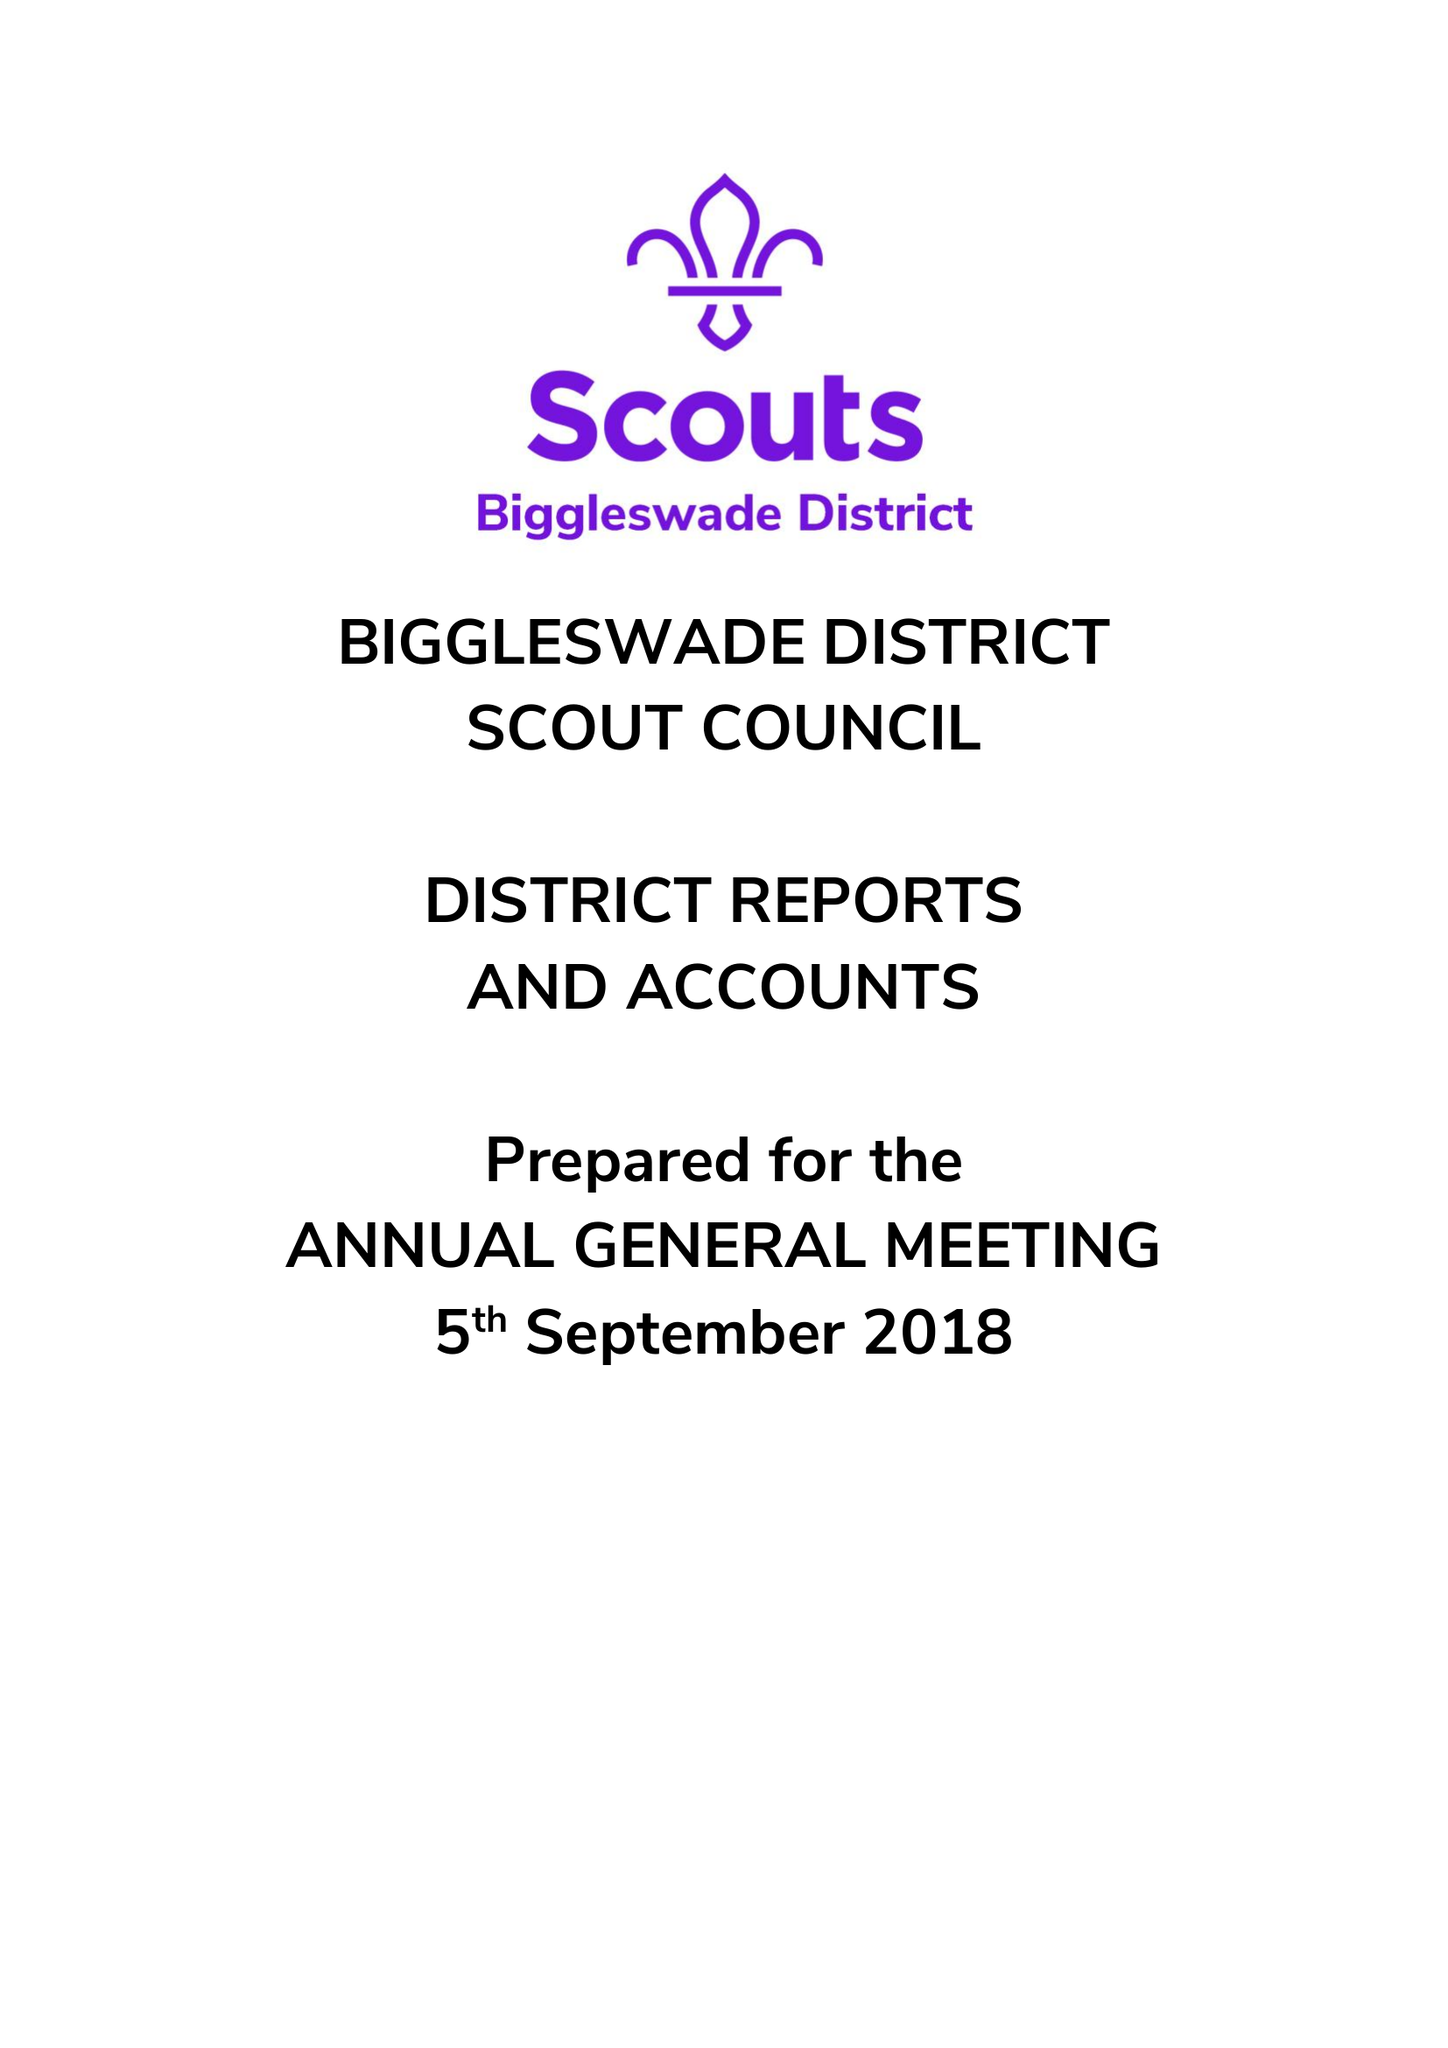What is the value for the charity_number?
Answer the question using a single word or phrase. 300458 